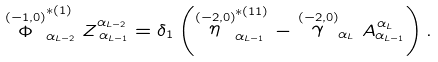<formula> <loc_0><loc_0><loc_500><loc_500>\stackrel { ( - 1 , 0 ) } { \Phi } _ { \alpha _ { L - 2 } } ^ { * ( 1 ) } Z _ { \, \alpha _ { L - 1 } } ^ { \alpha _ { L - 2 } } = \delta _ { 1 } \left ( \stackrel { ( - 2 , 0 ) } { \eta } _ { \alpha _ { L - 1 } } ^ { * ( 1 1 ) } - \stackrel { ( - 2 , 0 ) } { \gamma } _ { \alpha _ { L } } A _ { \alpha _ { L - 1 } } ^ { \, \alpha _ { L } } \right ) .</formula> 